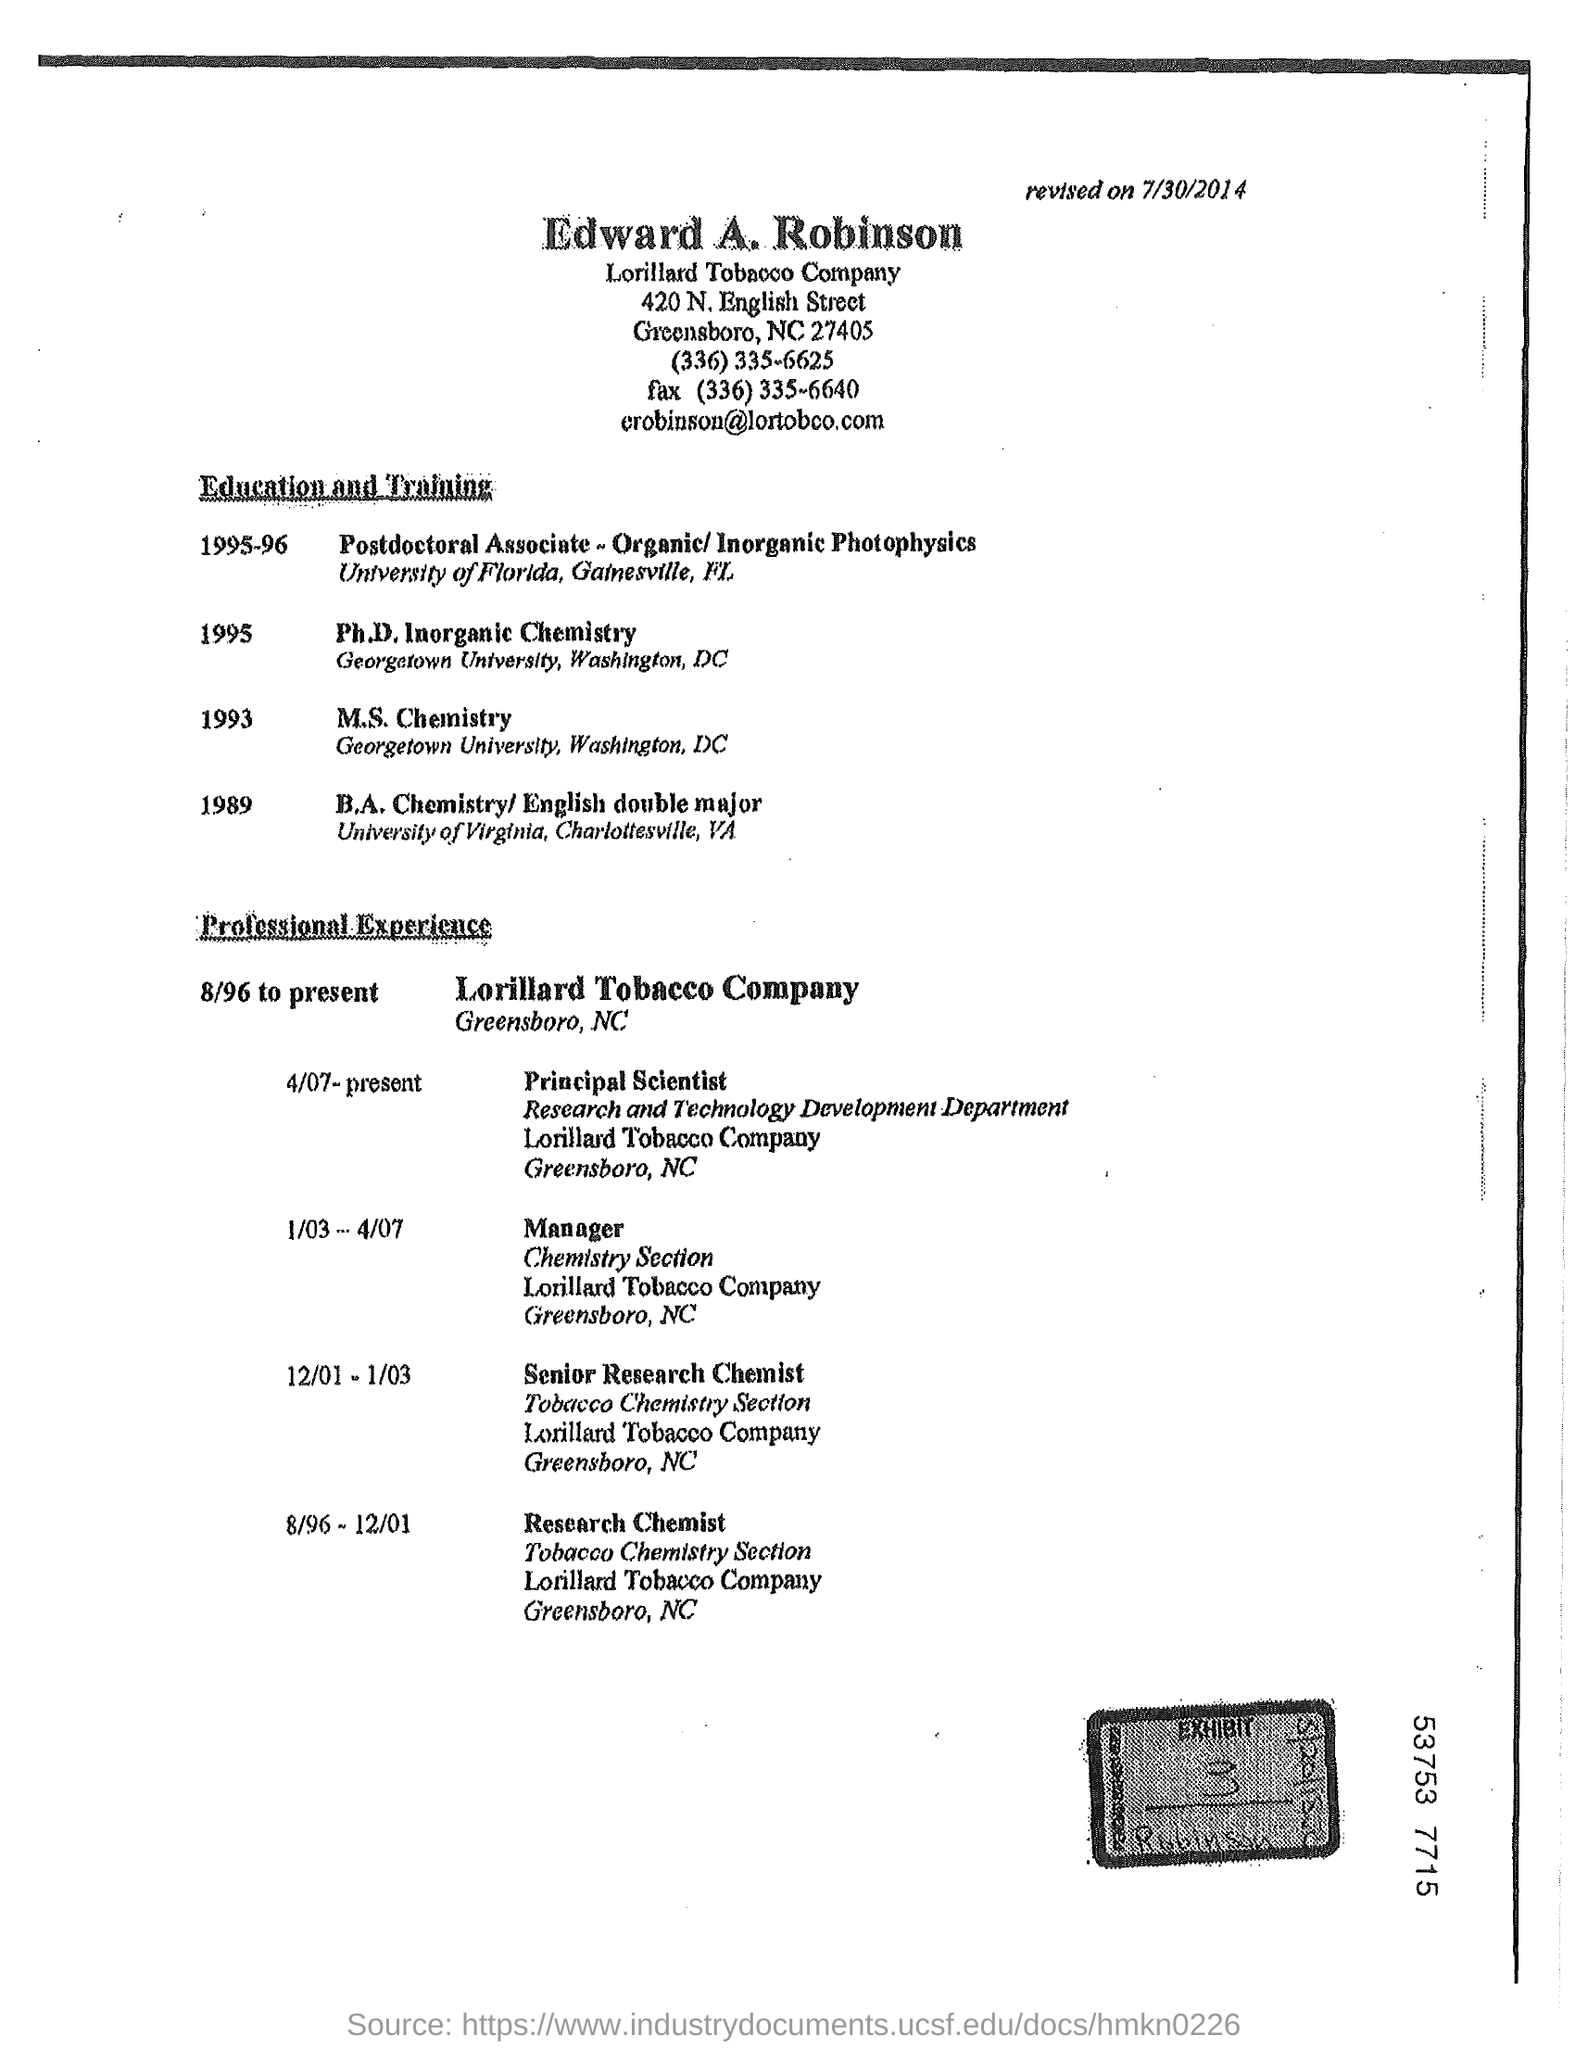What is the fax?
Offer a terse response. (336) 335-6640. 